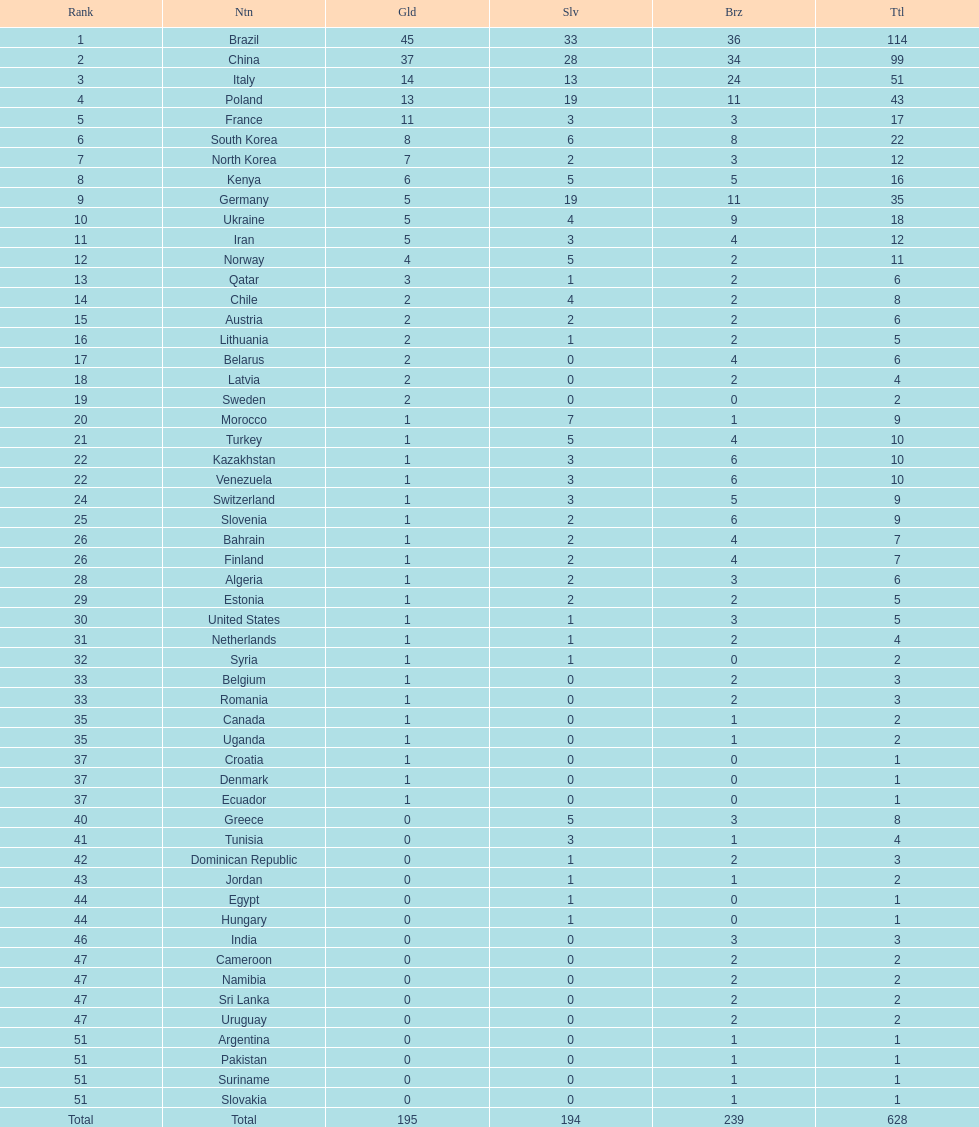How many total medals did norway win? 11. 